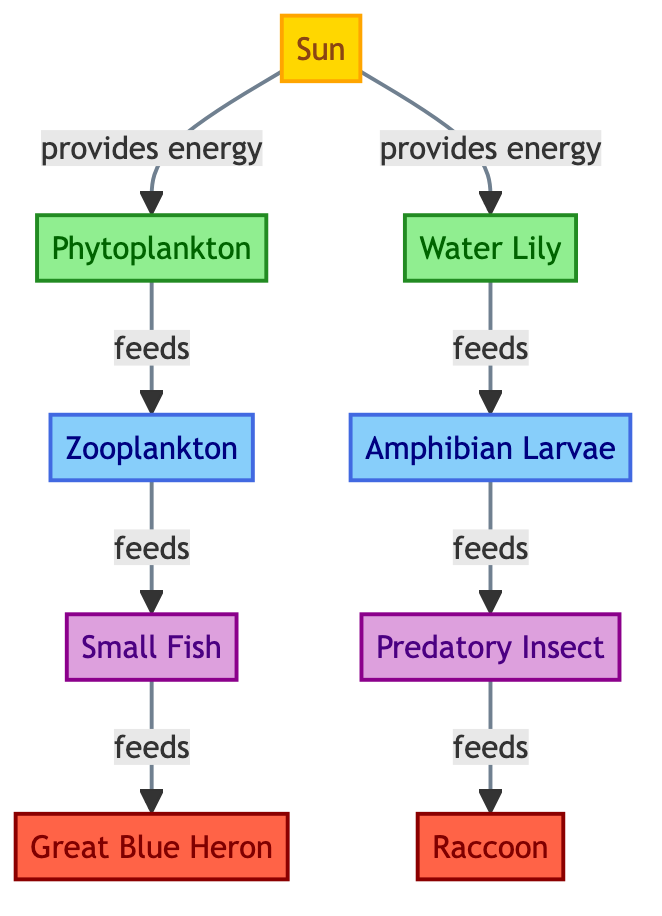What is the primary producer in the food chain? The primary producer in the food chain is indicated by the plant that directly uses sunlight to create energy. In the diagram, this is represented by "Phytoplankton" and "Water Lily."
Answer: Phytoplankton, Water Lily How many nodes are there in total? Counting all the entities present in the diagram, we identify the Sun, two producers (Phytoplankton and Water Lily), four primary consumers (Zooplankton, Small Fish, Amphibian Larvae, Predatory Insect), and two tertiary consumers (Great Blue Heron and Raccoon). This totals to nine nodes.
Answer: 9 Which organism feeds on the Zooplankton? The organism that feeds on the Zooplankton is directly connected to it in the diagram. Following the arrow from Zooplankton leads to "Small Fish."
Answer: Small Fish What type of relationship exists between the Water Lily and the Amphibian Larvae? The diagram shows a direct feeding relationship where the Water Lily provides food for the Amphibian Larvae. This relationship indicates that the Water Lily is a source of energy for the Amphibian Larvae.
Answer: Feeding Which laurel organism is at the highest trophic level in the food chain? The highest trophic level indicates the top predator in the food chain, which can be seen at the top of the feeding hierarchy. In this case, the "Raccoon" is the organism positioned at the highest trophic level.
Answer: Raccoon How many organisms are primary consumers in this wetland food chain? Analyzing the diagram, there are four primary consumers that receive energy directly from producers, which are "Zooplankton," "Small Fish," "Amphibian Larvae," and "Predatory Insect."
Answer: 4 Which organism is the initial source of energy in this food chain? The flow of energy begins with the Sun, which is the most fundamental source of energy for the ecosystem depicted in the food chain. Therefore, it is identified as the initial energy source.
Answer: Sun What flows from Phytoplankton to Zooplankton? The diagram illustrates the flow of nutrients and energy from Phytoplankton, which serves as a food source for Zooplankton. Hence, they are related through a feeding relationship.
Answer: Energy What is the role of the Great Blue Heron in the food chain? The Great Blue Heron is represented as a tertiary consumer in the food chain, indicating that it feeds on smaller organisms such as "Small Fish."
Answer: Tertiary consumer 